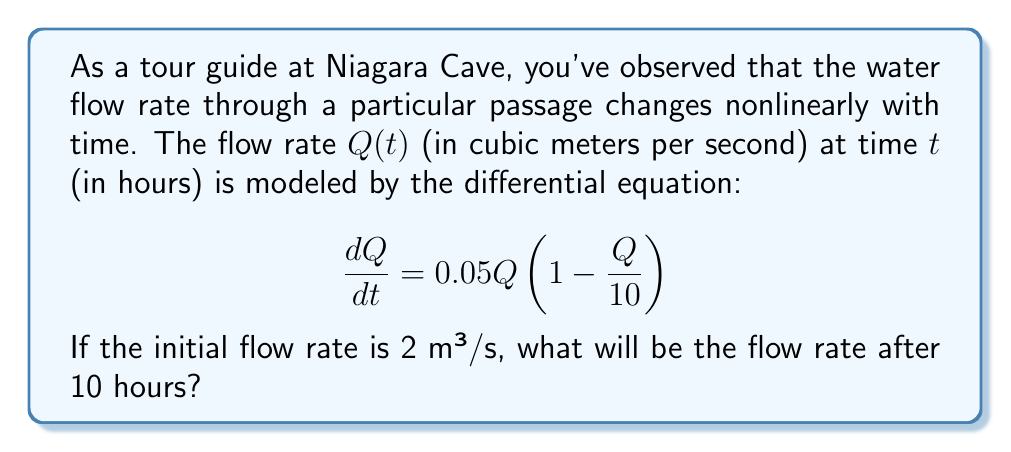Could you help me with this problem? To solve this problem, we need to use the given nonlinear differential equation and apply the initial condition. Let's proceed step by step:

1) The given differential equation is a logistic growth model:
   $$\frac{dQ}{dt} = 0.05Q(1 - \frac{Q}{10})$$

2) This equation can be solved using separation of variables:
   $$\int \frac{dQ}{Q(1 - \frac{Q}{10})} = \int 0.05 dt$$

3) The left side can be decomposed using partial fractions:
   $$\int (\frac{1}{Q} + \frac{1/10}{1 - Q/10}) dQ = 0.05t + C$$

4) Integrating both sides:
   $$\ln|Q| - \ln|10 - Q| = 0.5t + C$$

5) Simplifying:
   $$\ln|\frac{Q}{10 - Q}| = 0.5t + C$$

6) Applying the initial condition: $Q(0) = 2$
   $$\ln|\frac{2}{8}| = C$$
   $$C = -1.386$$

7) Substituting back:
   $$\ln|\frac{Q}{10 - Q}| = 0.5t - 1.386$$

8) Solving for Q:
   $$\frac{Q}{10 - Q} = e^{0.5t - 1.386}$$
   $$Q = \frac{10e^{0.5t - 1.386}}{1 + e^{0.5t - 1.386}}$$

9) For $t = 10$:
   $$Q(10) = \frac{10e^{5 - 1.386}}{1 + e^{5 - 1.386}} \approx 9.323$$

Therefore, after 10 hours, the flow rate will be approximately 9.323 m³/s.
Answer: 9.323 m³/s 